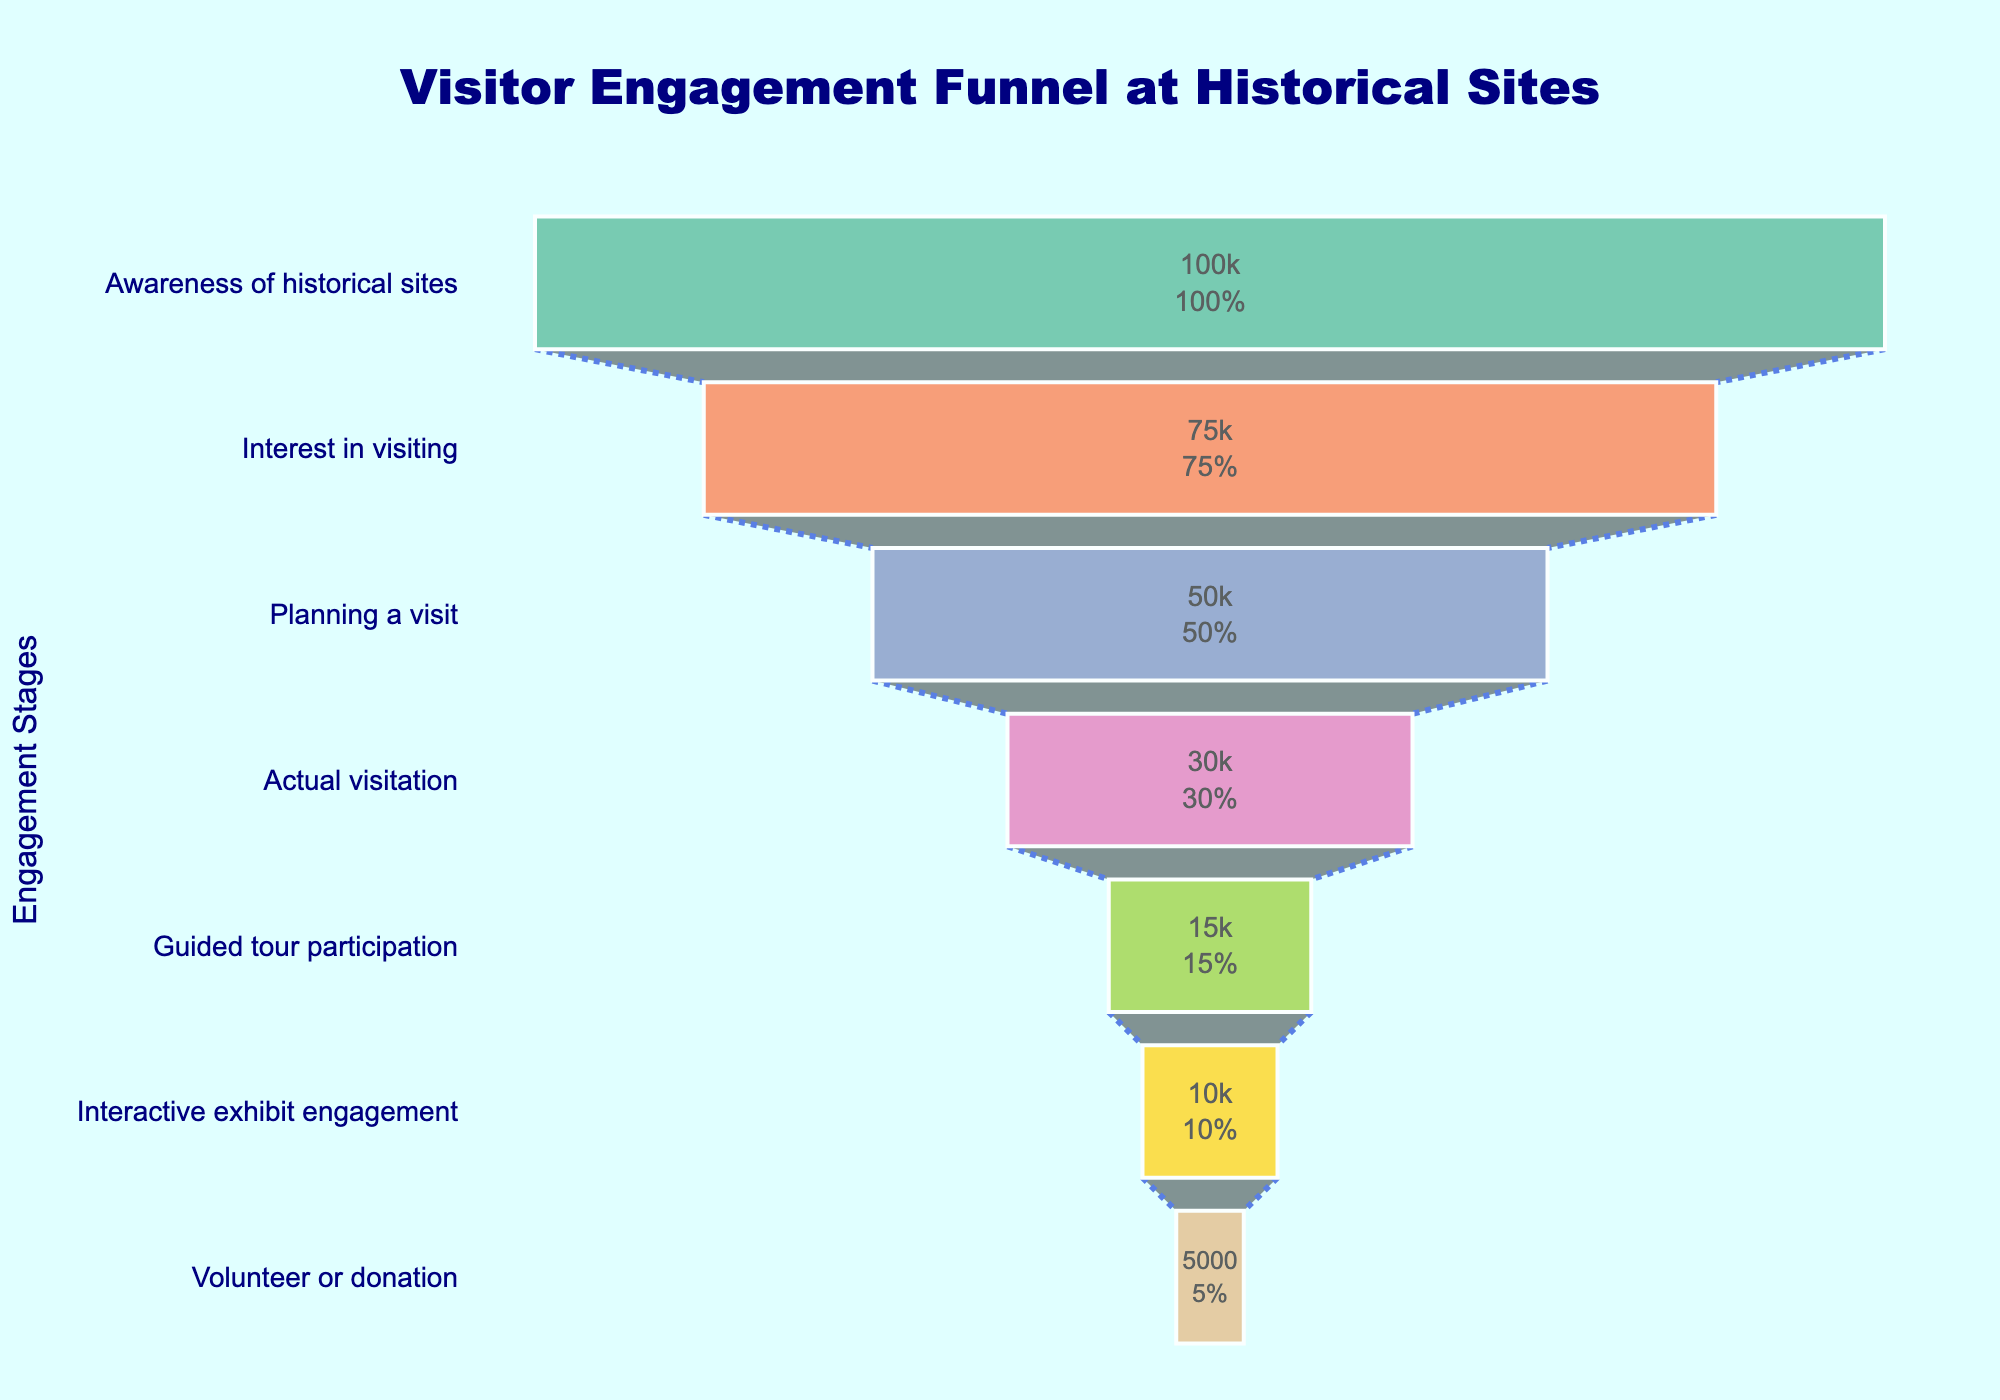How many visitors are aware of historical sites? The first stage, "Awareness of historical sites," shows the number of visitors at this level.
Answer: 100,000 What is the ratio of visitors interested in visiting compared to those aware of historical sites? To find the ratio, divide the visitors interested in visiting (75,000) by those aware of historical sites (100,000). 75,000 / 100,000 = 0.75
Answer: 0.75 How many visitors move from interest in visiting to planning a visit? Subtract the number of visitors planning a visit (50,000) from those interested in visiting (75,000). 75,000 - 50,000 = 25,000
Answer: 25,000 Which stage has the highest number of visitors? The highest number of visitors is shown in the first stage, "Awareness of historical sites," which has 100,000 visitors.
Answer: Awareness of historical sites What percentage of visitors actually visit compared to those initially aware of historical sites? To find the percentage, divide the number of actual visitors (30,000) by those initially aware of historical sites (100,000) and multiply by 100. (30,000 / 100,000) * 100 = 30%
Answer: 30% What is the difference in the number of visitors between the stages "Actual visitation" and "Guided tour participation"? Subtract the number of visitors in "Guided tour participation" (15,000) from those in "Actual visitation" (30,000). 30,000 - 15,000 = 15,000
Answer: 15,000 At which stage do the visitor numbers halve compared to the previous stage for the first time? Visitor numbers drop from "Interest in visiting" (75,000) to "Planning a visit" (50,000) and then to "Actual visitation" (30,000). The first halving occurs between "Actual visitation" (30,000) and "Guided tour participation" (15,000).
Answer: Guided tour participation What is the combined total number of visitors who engage with interactive exhibits and those who volunteer or donate? Add the number of visitors at "Interactive exhibit engagement" (10,000) and "Volunteer or donation" (5,000). 10,000 + 5,000 = 15,000
Answer: 15,000 Which stage shows the largest decrease in visitor numbers compared to its previous stage? Calculate the differences between consecutive stages: 100,000 to 75,000 (25,000), 75,000 to 50,000 (25,000), 50,000 to 30,000 (20,000), 30,000 to 15,000 (15,000), 15,000 to 10,000 (5,000), 10,000 to 5,000 (5,000). The largest decrease is from "Planning a visit" to "Actual visitation" (20,000).
Answer: Actual visitation How many visitors drop off between the "Interactive exhibit engagement" and the final stage? Subtract the number of visitors in "Volunteer or donation" (5,000) from those in "Interactive exhibit engagement" (10,000). 10,000 - 5,000 = 5,000
Answer: 5,000 